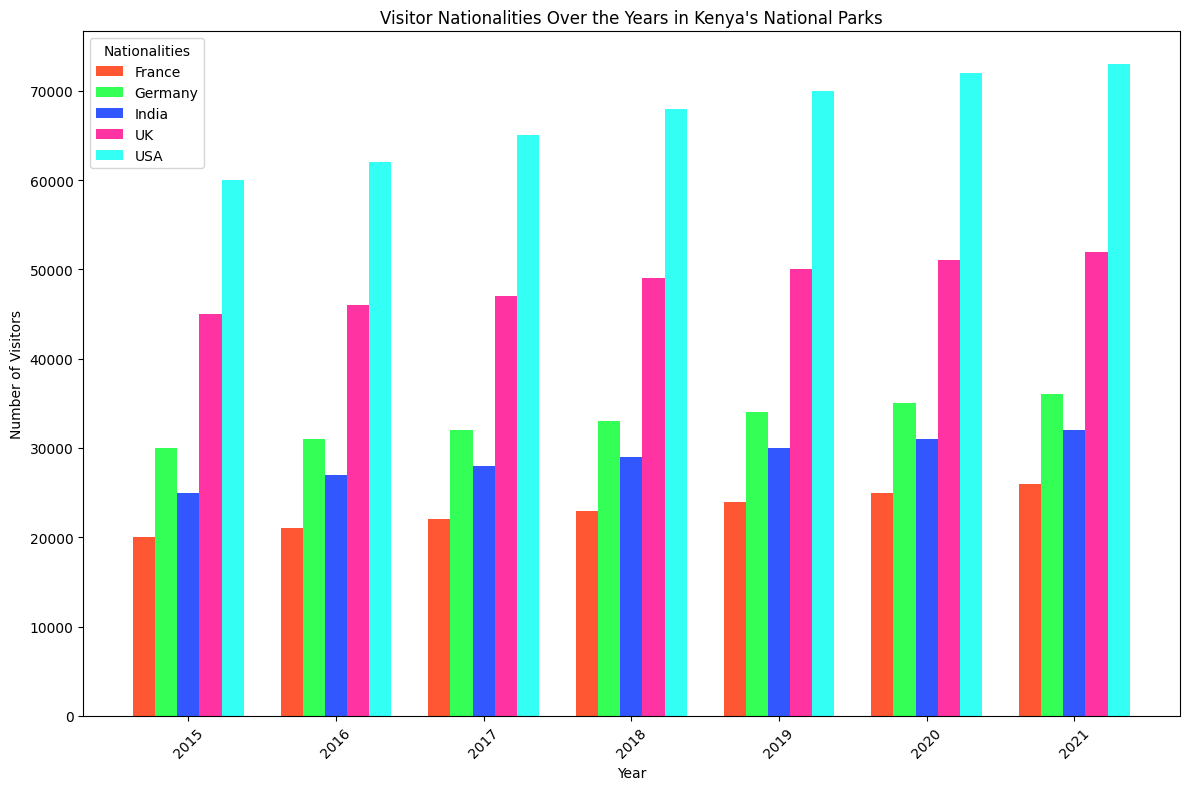What's the trend in the number of visitors from the USA over the years? To determine the trend, observe the height of the bars representing the USA from 2015 to 2021. The bars increase in height each year.
Answer: Increasing Which nationality had the highest number of visitors in 2021? Look at the 2021 section of the chart and identify the tallest bar. The tallest bar corresponds to the USA.
Answer: USA How does the number of visitors from Germany in 2019 compare to those from France in the same year? Compare the heights of the bars for Germany and France in 2019. The height of the bar for Germany is higher than that of France.
Answer: Germany had more visitors What is the average number of visitors from the UK between 2018 and 2020? Sum the number of visitors from the UK for 2018, 2019, and 2020: 49000 + 50000 + 51000 = 150000. Divide by 3 to get the average: 150000/3 = 50000.
Answer: 50000 Which two nationalities had the closest number of visitors in 2020? Examine the 2020 bars and compare their heights. Germany and India have the closest numbers of visitors.
Answer: Germany and India By how much did the number of visitors from India increase from 2016 to 2021? Subtract the number of visitors from India in 2016 (27000) from the number in 2021 (32000): 32000 - 27000 = 5000.
Answer: 5000 Which nationality shows the smallest growth in visitors from 2015 to 2021? Look at the difference in height from 2015 to 2021 for each nationality. France shows the smallest increase.
Answer: France What’s the percentage increase in the number of visitors from the USA from 2015 to 2021? Calculate the difference in the number of visitors from 2015 (60000) to 2021 (73000): 73000 - 60000 = 13000. Divide by the 2015 number and multiply by 100: (13000/60000) * 100 ≈ 21.67%.
Answer: 21.67% How did the number of visitors from France change from 2015 to 2020? Compare the heights of the bars for France in 2015 and 2020. The height increases from 20000 in 2015 to 25000 in 2020.
Answer: Increased by 5000 